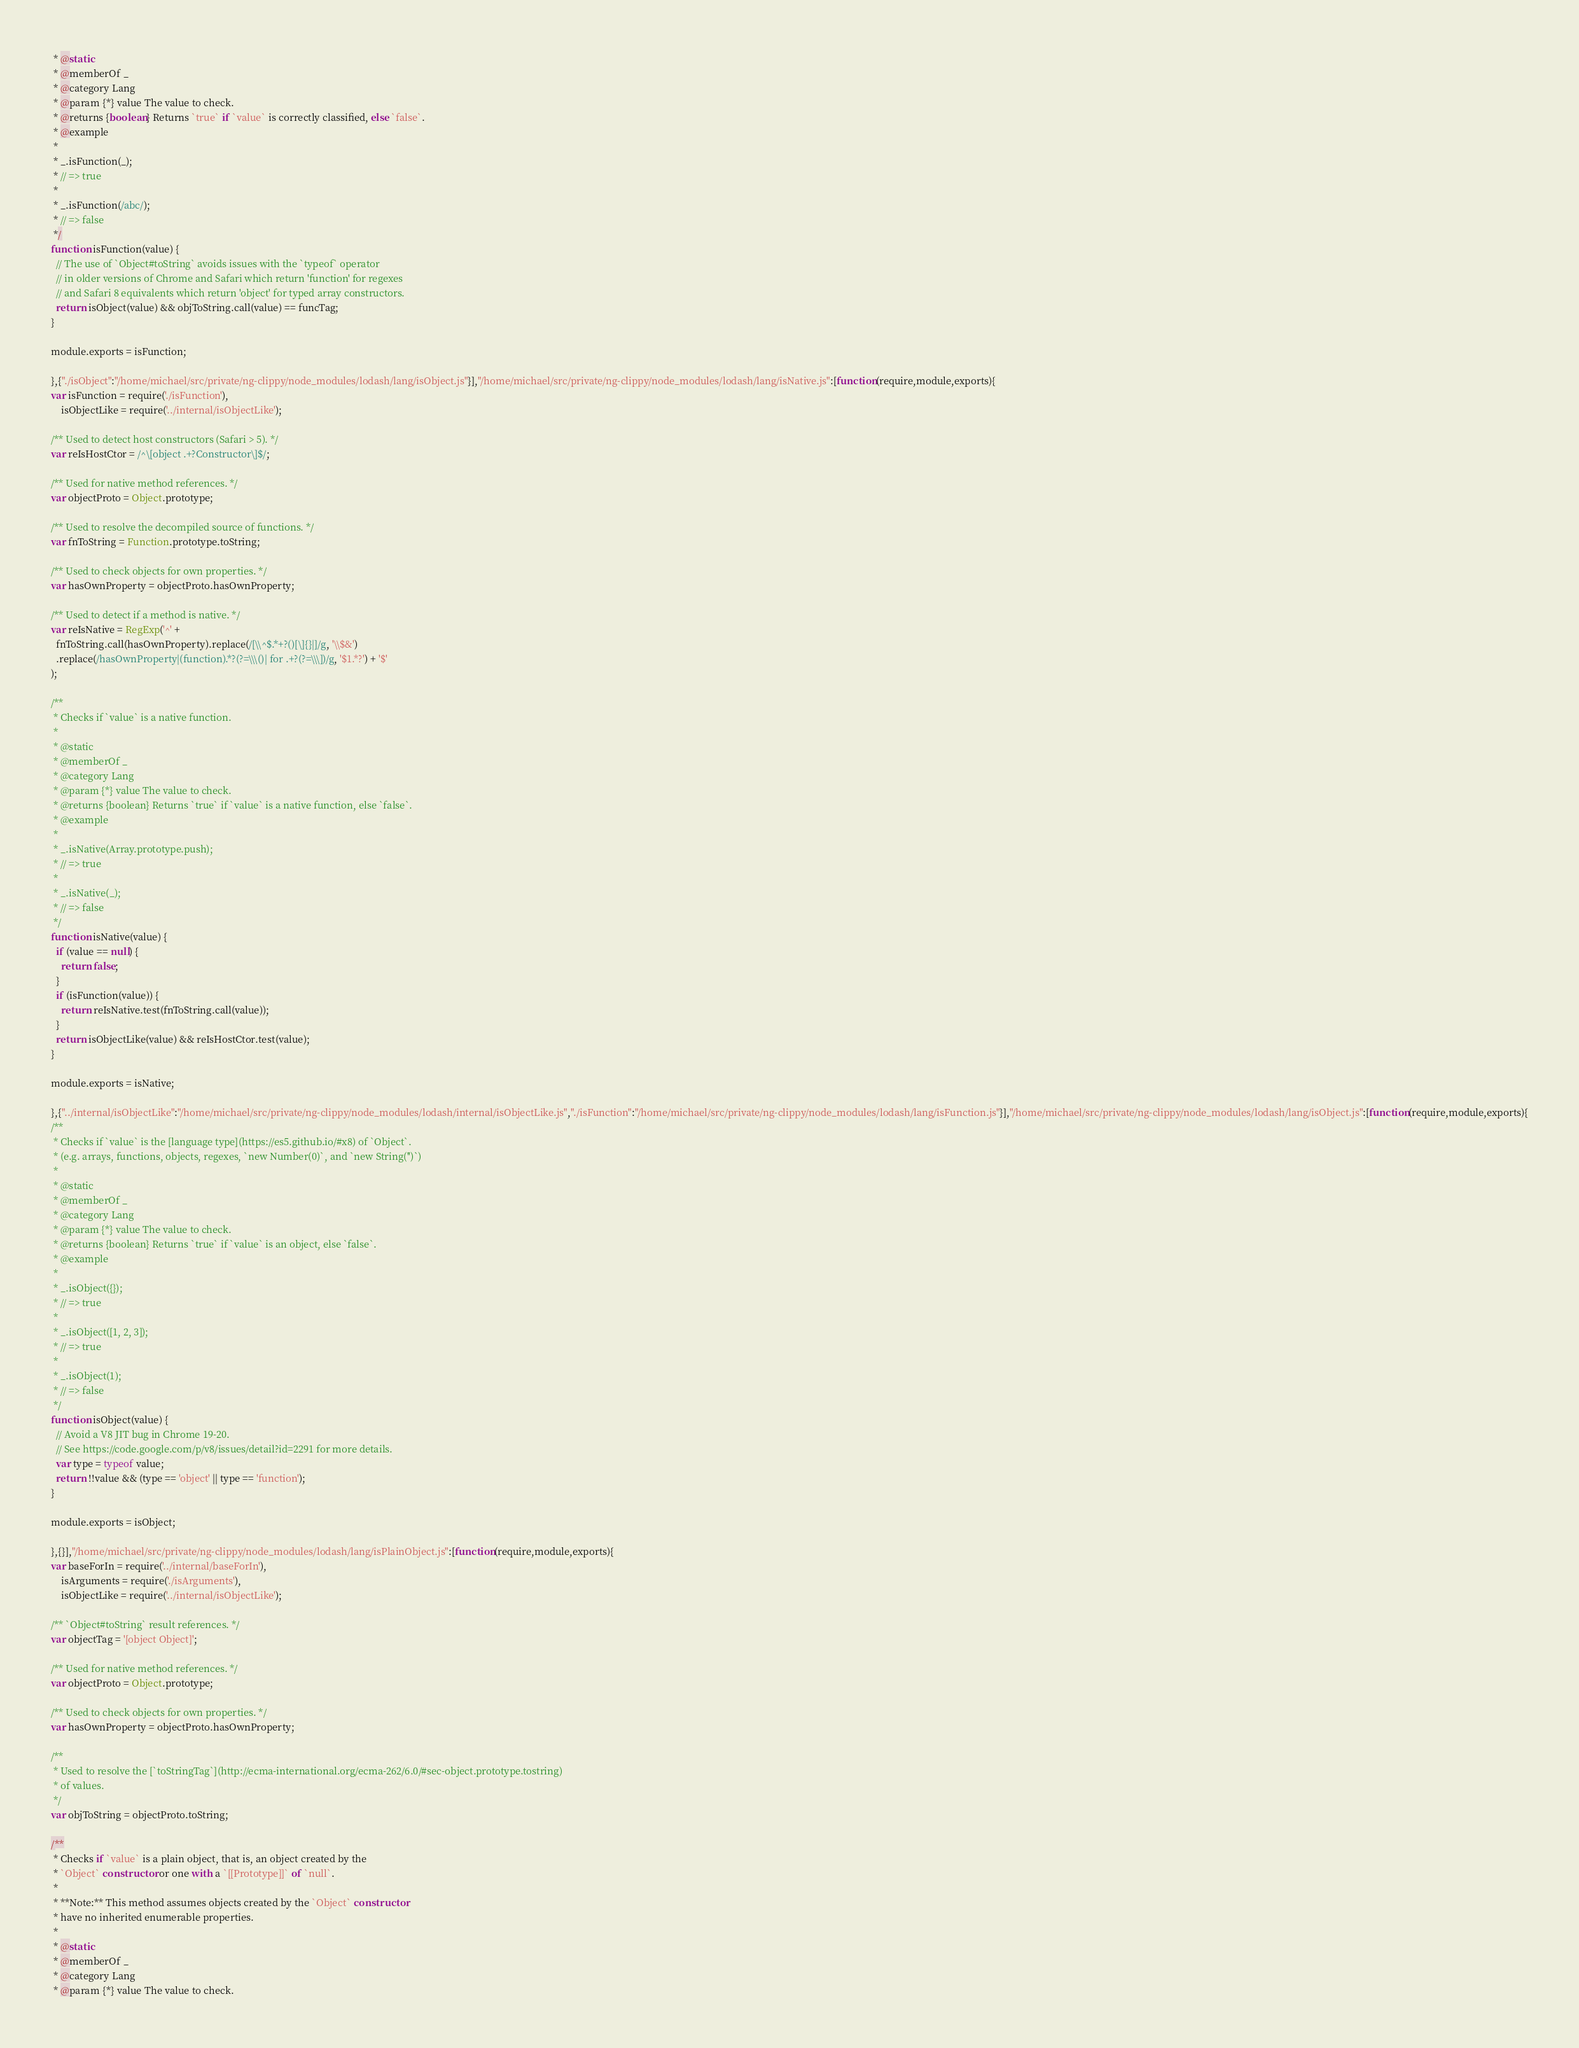Convert code to text. <code><loc_0><loc_0><loc_500><loc_500><_JavaScript_> * @static
 * @memberOf _
 * @category Lang
 * @param {*} value The value to check.
 * @returns {boolean} Returns `true` if `value` is correctly classified, else `false`.
 * @example
 *
 * _.isFunction(_);
 * // => true
 *
 * _.isFunction(/abc/);
 * // => false
 */
function isFunction(value) {
  // The use of `Object#toString` avoids issues with the `typeof` operator
  // in older versions of Chrome and Safari which return 'function' for regexes
  // and Safari 8 equivalents which return 'object' for typed array constructors.
  return isObject(value) && objToString.call(value) == funcTag;
}

module.exports = isFunction;

},{"./isObject":"/home/michael/src/private/ng-clippy/node_modules/lodash/lang/isObject.js"}],"/home/michael/src/private/ng-clippy/node_modules/lodash/lang/isNative.js":[function(require,module,exports){
var isFunction = require('./isFunction'),
    isObjectLike = require('../internal/isObjectLike');

/** Used to detect host constructors (Safari > 5). */
var reIsHostCtor = /^\[object .+?Constructor\]$/;

/** Used for native method references. */
var objectProto = Object.prototype;

/** Used to resolve the decompiled source of functions. */
var fnToString = Function.prototype.toString;

/** Used to check objects for own properties. */
var hasOwnProperty = objectProto.hasOwnProperty;

/** Used to detect if a method is native. */
var reIsNative = RegExp('^' +
  fnToString.call(hasOwnProperty).replace(/[\\^$.*+?()[\]{}|]/g, '\\$&')
  .replace(/hasOwnProperty|(function).*?(?=\\\()| for .+?(?=\\\])/g, '$1.*?') + '$'
);

/**
 * Checks if `value` is a native function.
 *
 * @static
 * @memberOf _
 * @category Lang
 * @param {*} value The value to check.
 * @returns {boolean} Returns `true` if `value` is a native function, else `false`.
 * @example
 *
 * _.isNative(Array.prototype.push);
 * // => true
 *
 * _.isNative(_);
 * // => false
 */
function isNative(value) {
  if (value == null) {
    return false;
  }
  if (isFunction(value)) {
    return reIsNative.test(fnToString.call(value));
  }
  return isObjectLike(value) && reIsHostCtor.test(value);
}

module.exports = isNative;

},{"../internal/isObjectLike":"/home/michael/src/private/ng-clippy/node_modules/lodash/internal/isObjectLike.js","./isFunction":"/home/michael/src/private/ng-clippy/node_modules/lodash/lang/isFunction.js"}],"/home/michael/src/private/ng-clippy/node_modules/lodash/lang/isObject.js":[function(require,module,exports){
/**
 * Checks if `value` is the [language type](https://es5.github.io/#x8) of `Object`.
 * (e.g. arrays, functions, objects, regexes, `new Number(0)`, and `new String('')`)
 *
 * @static
 * @memberOf _
 * @category Lang
 * @param {*} value The value to check.
 * @returns {boolean} Returns `true` if `value` is an object, else `false`.
 * @example
 *
 * _.isObject({});
 * // => true
 *
 * _.isObject([1, 2, 3]);
 * // => true
 *
 * _.isObject(1);
 * // => false
 */
function isObject(value) {
  // Avoid a V8 JIT bug in Chrome 19-20.
  // See https://code.google.com/p/v8/issues/detail?id=2291 for more details.
  var type = typeof value;
  return !!value && (type == 'object' || type == 'function');
}

module.exports = isObject;

},{}],"/home/michael/src/private/ng-clippy/node_modules/lodash/lang/isPlainObject.js":[function(require,module,exports){
var baseForIn = require('../internal/baseForIn'),
    isArguments = require('./isArguments'),
    isObjectLike = require('../internal/isObjectLike');

/** `Object#toString` result references. */
var objectTag = '[object Object]';

/** Used for native method references. */
var objectProto = Object.prototype;

/** Used to check objects for own properties. */
var hasOwnProperty = objectProto.hasOwnProperty;

/**
 * Used to resolve the [`toStringTag`](http://ecma-international.org/ecma-262/6.0/#sec-object.prototype.tostring)
 * of values.
 */
var objToString = objectProto.toString;

/**
 * Checks if `value` is a plain object, that is, an object created by the
 * `Object` constructor or one with a `[[Prototype]]` of `null`.
 *
 * **Note:** This method assumes objects created by the `Object` constructor
 * have no inherited enumerable properties.
 *
 * @static
 * @memberOf _
 * @category Lang
 * @param {*} value The value to check.</code> 